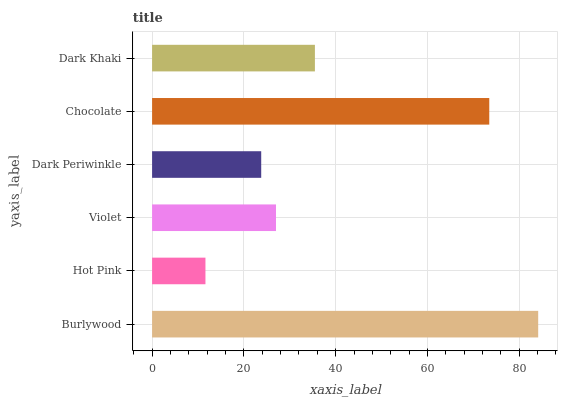Is Hot Pink the minimum?
Answer yes or no. Yes. Is Burlywood the maximum?
Answer yes or no. Yes. Is Violet the minimum?
Answer yes or no. No. Is Violet the maximum?
Answer yes or no. No. Is Violet greater than Hot Pink?
Answer yes or no. Yes. Is Hot Pink less than Violet?
Answer yes or no. Yes. Is Hot Pink greater than Violet?
Answer yes or no. No. Is Violet less than Hot Pink?
Answer yes or no. No. Is Dark Khaki the high median?
Answer yes or no. Yes. Is Violet the low median?
Answer yes or no. Yes. Is Chocolate the high median?
Answer yes or no. No. Is Dark Khaki the low median?
Answer yes or no. No. 